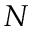Convert formula to latex. <formula><loc_0><loc_0><loc_500><loc_500>N</formula> 